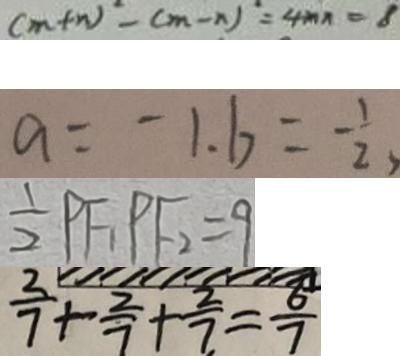Convert formula to latex. <formula><loc_0><loc_0><loc_500><loc_500>( m + n ) ^ { 2 } - ( m - n ) ^ { 2 } = 4 m n = 8 
 a = - 1 . b = - \frac { 1 } { 2 } 
 \frac { 1 } { 2 } P F _ { 1 } P F _ { 2 } = 9 
 \frac { 2 } { 7 } + \frac { 2 } { 7 } + \frac { 2 } { 7 } = \frac { 6 } { 7 }</formula> 